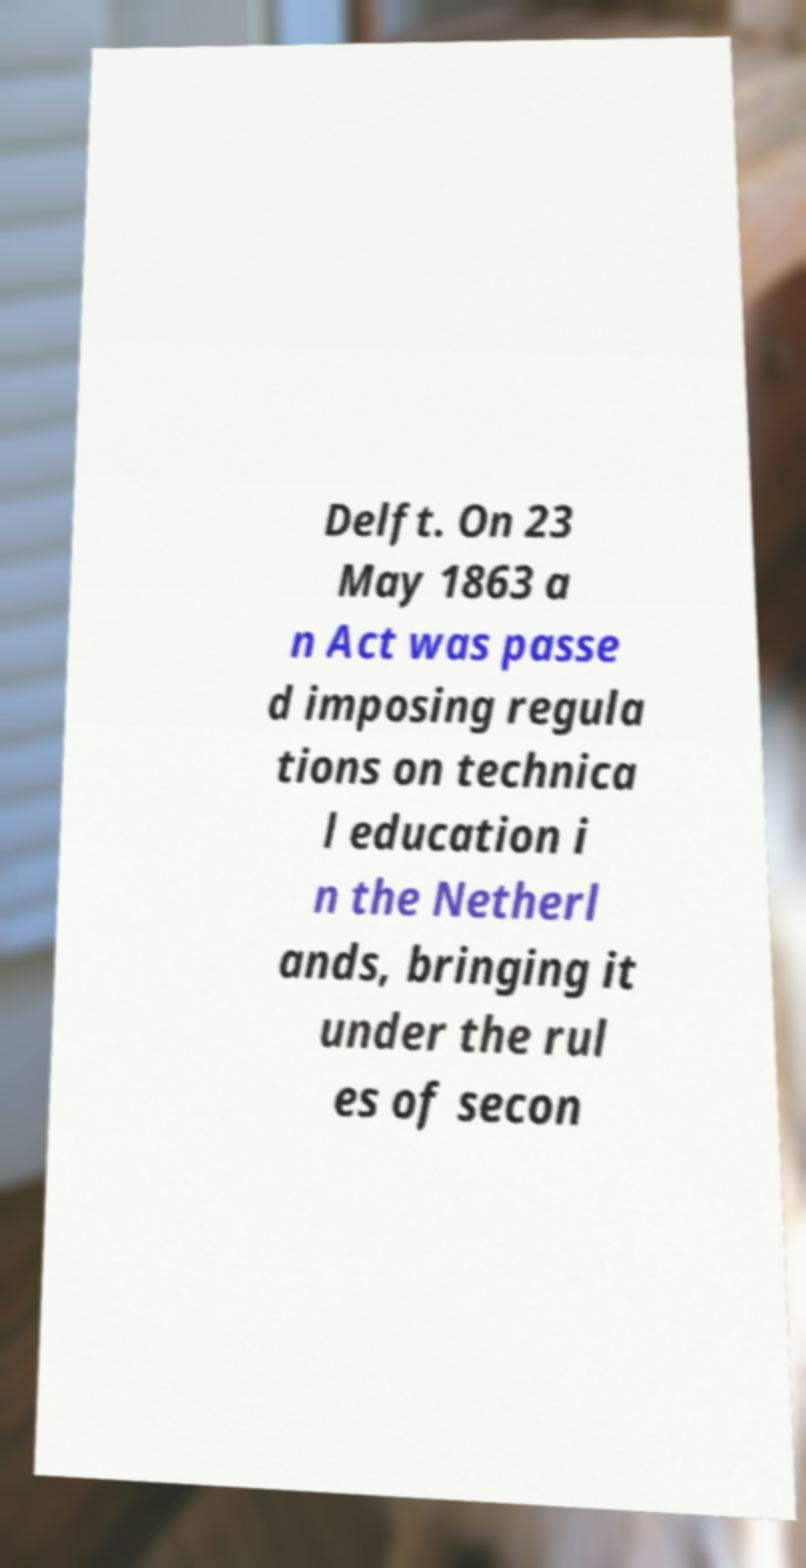What messages or text are displayed in this image? I need them in a readable, typed format. Delft. On 23 May 1863 a n Act was passe d imposing regula tions on technica l education i n the Netherl ands, bringing it under the rul es of secon 